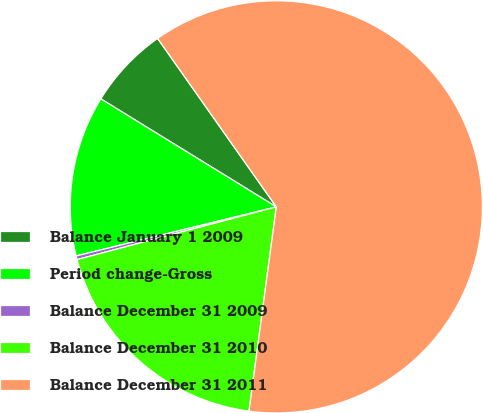Convert chart. <chart><loc_0><loc_0><loc_500><loc_500><pie_chart><fcel>Balance January 1 2009<fcel>Period change-Gross<fcel>Balance December 31 2009<fcel>Balance December 31 2010<fcel>Balance December 31 2011<nl><fcel>6.45%<fcel>12.61%<fcel>0.29%<fcel>18.77%<fcel>61.89%<nl></chart> 